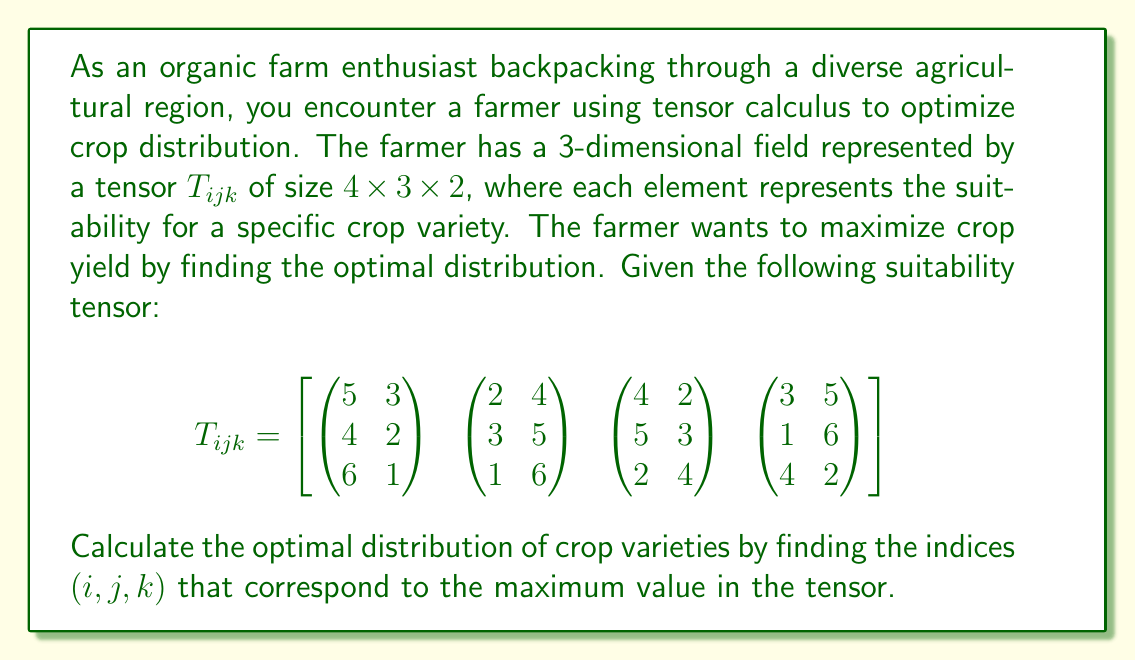Help me with this question. To find the optimal distribution of crop varieties, we need to locate the maximum value in the given tensor $T_{ijk}$. This can be done by comparing all elements of the tensor. Let's break it down step-by-step:

1) First, let's understand the structure of the tensor:
   - It has dimensions $4 \times 3 \times 2$
   - $i$ ranges from 1 to 4
   - $j$ ranges from 1 to 3
   - $k$ ranges from 1 to 2

2) Now, let's examine each "slice" of the tensor:

   For $i = 1$:
   $$\begin{pmatrix} 5 & 3 \\ 4 & 2 \\ 6 & 1 \end{pmatrix}$$

   For $i = 2$:
   $$\begin{pmatrix} 2 & 4 \\ 3 & 5 \\ 1 & 6 \end{pmatrix}$$

   For $i = 3$:
   $$\begin{pmatrix} 4 & 2 \\ 5 & 3 \\ 2 & 4 \end{pmatrix}$$

   For $i = 4$:
   $$\begin{pmatrix} 3 & 5 \\ 1 & 6 \\ 4 & 2 \end{pmatrix}$$

3) To find the maximum value, we compare all elements:
   The largest value in the tensor is 6, which appears three times:
   - At $(1,3,1)$
   - At $(2,3,2)$
   - At $(4,2,2)$

4) Since we have multiple occurrences of the maximum value, we can choose any of these positions as the optimal distribution. Let's select the first occurrence: $(1,3,1)$.

Thus, the optimal distribution of crop varieties corresponds to the indices $(i,j,k) = (1,3,1)$.
Answer: $(1,3,1)$ 